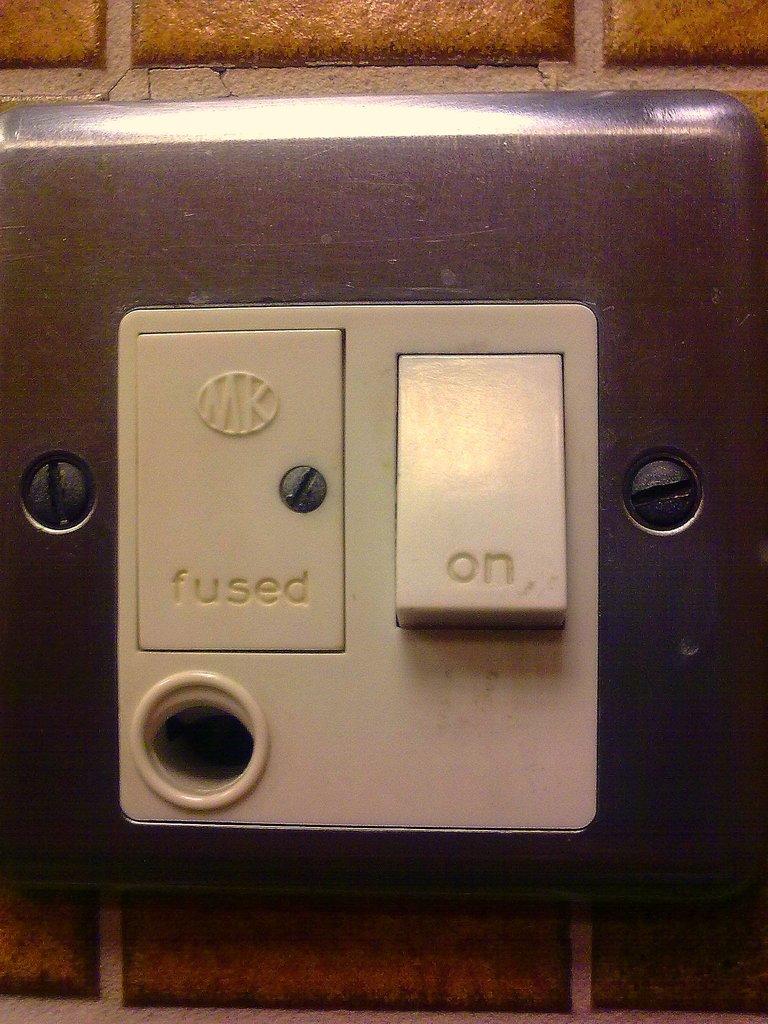What does the button say on the right?
Offer a terse response. On. 